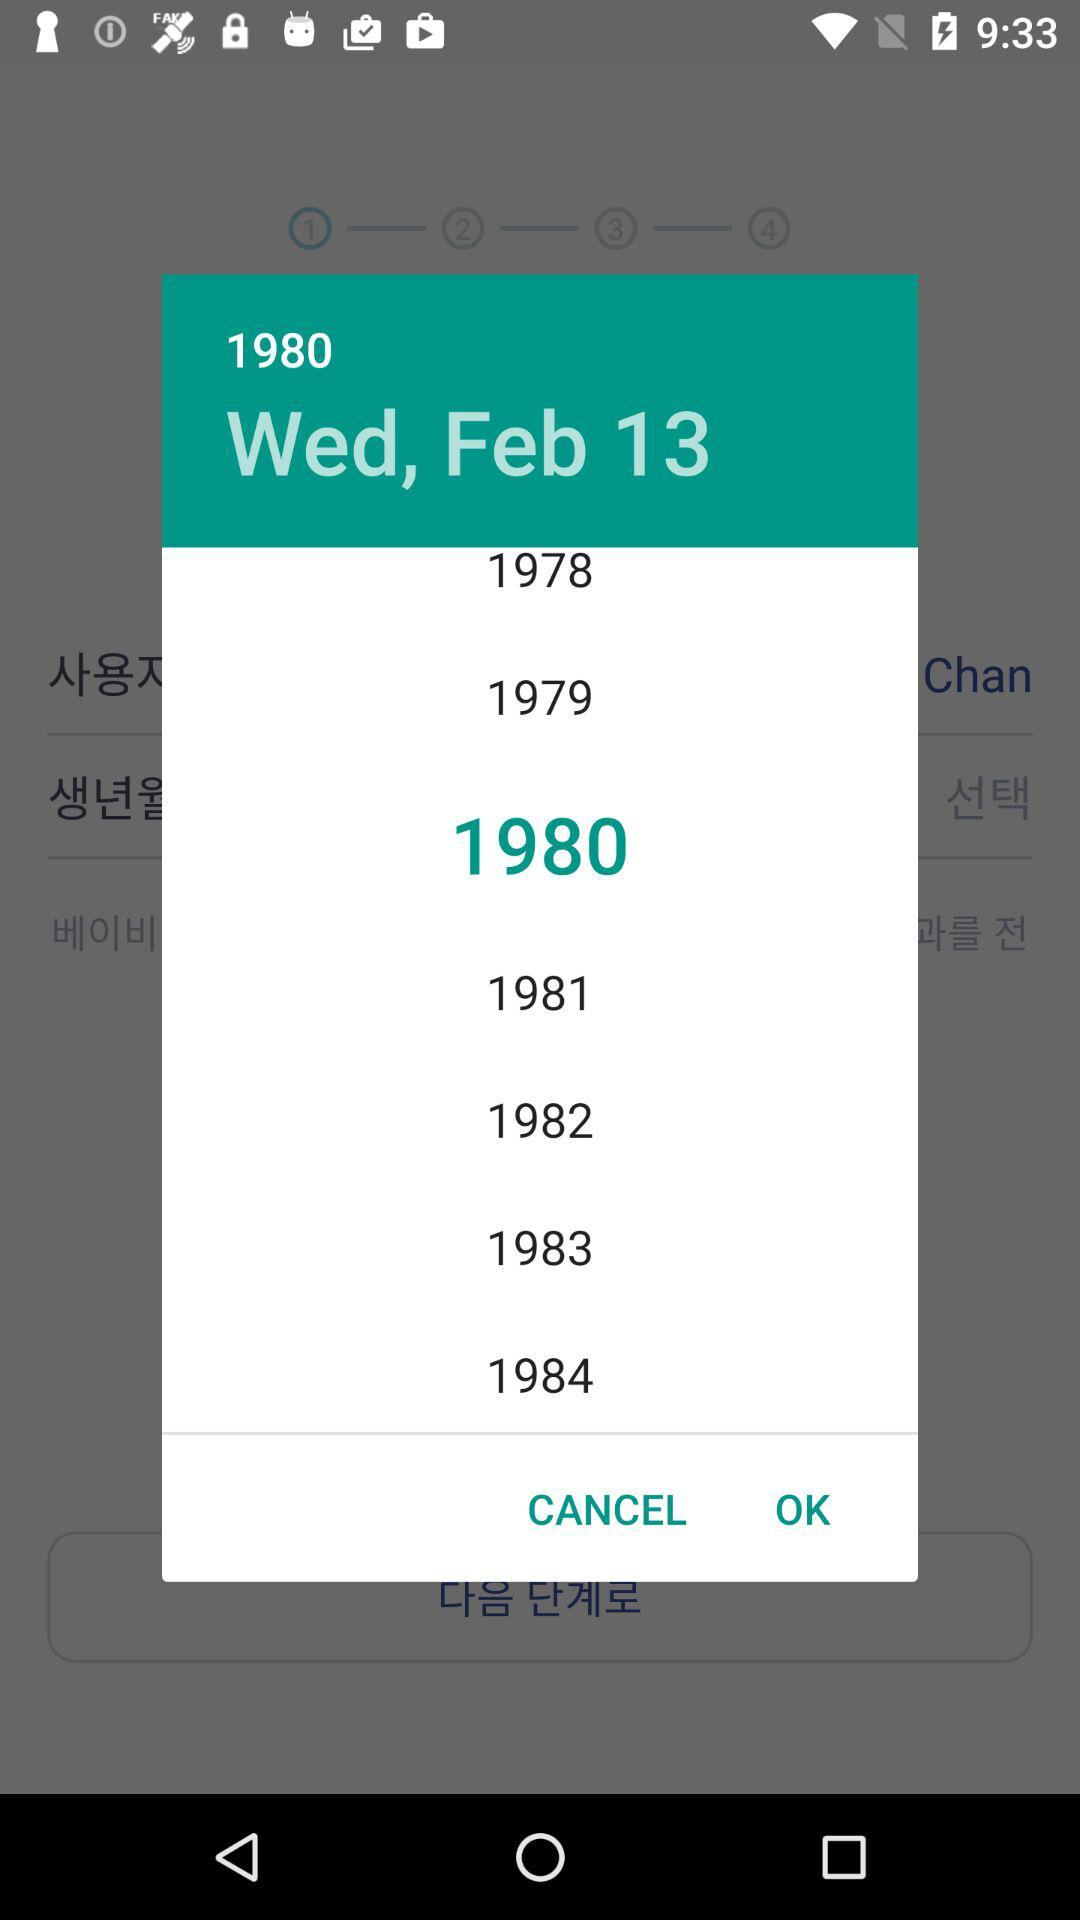What day is February 13? The day is Wednesday. 